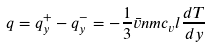<formula> <loc_0><loc_0><loc_500><loc_500>q = q _ { y } ^ { + } - q _ { y } ^ { - } = - { \frac { 1 } { 3 } } { \bar { v } } n m c _ { v } l { \frac { d T } { d y } }</formula> 